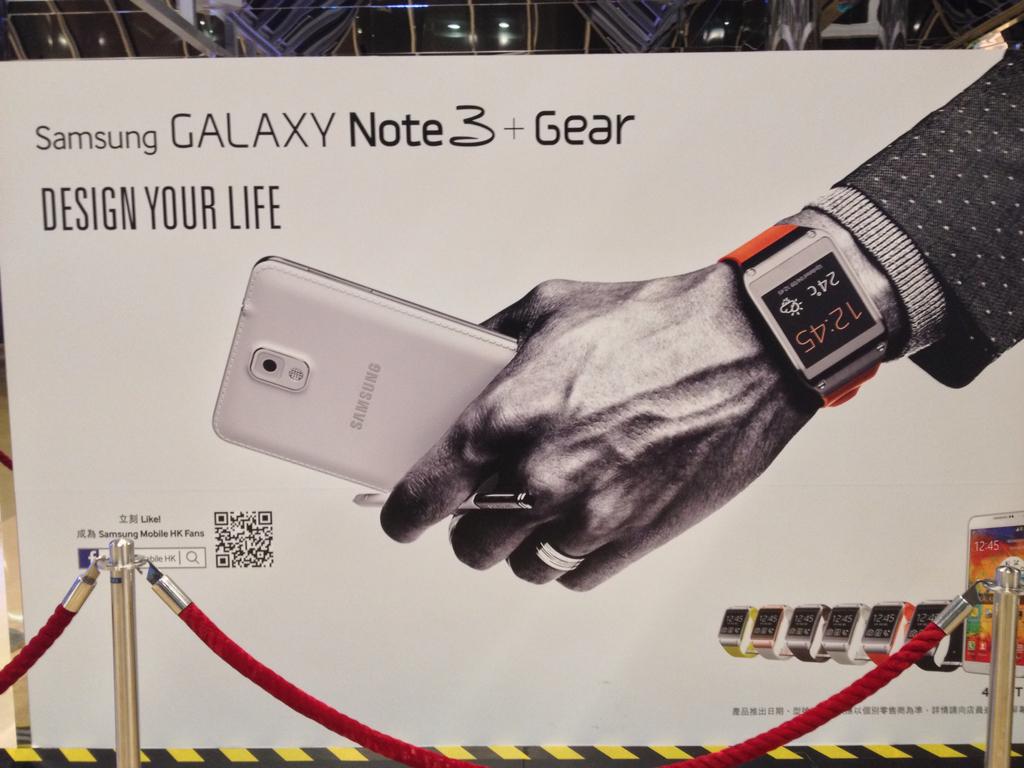What brand is the laptop?
Keep it short and to the point. Samsung. Which model is being advertised?
Provide a short and direct response. Galaxy note 3. 